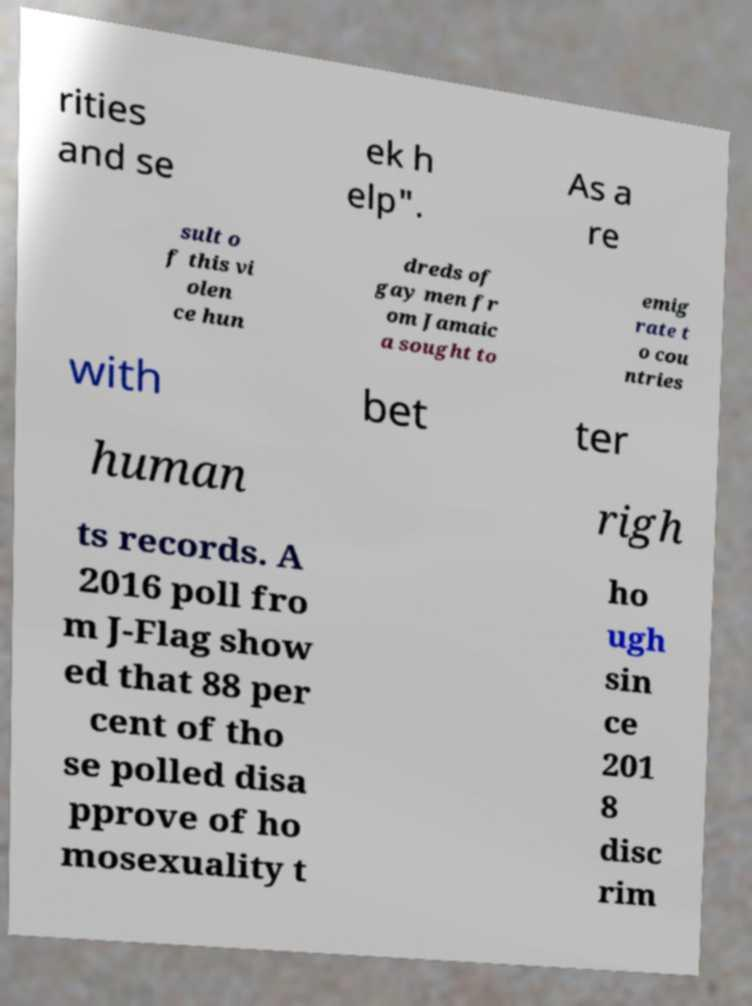Could you assist in decoding the text presented in this image and type it out clearly? rities and se ek h elp". As a re sult o f this vi olen ce hun dreds of gay men fr om Jamaic a sought to emig rate t o cou ntries with bet ter human righ ts records. A 2016 poll fro m J-Flag show ed that 88 per cent of tho se polled disa pprove of ho mosexuality t ho ugh sin ce 201 8 disc rim 